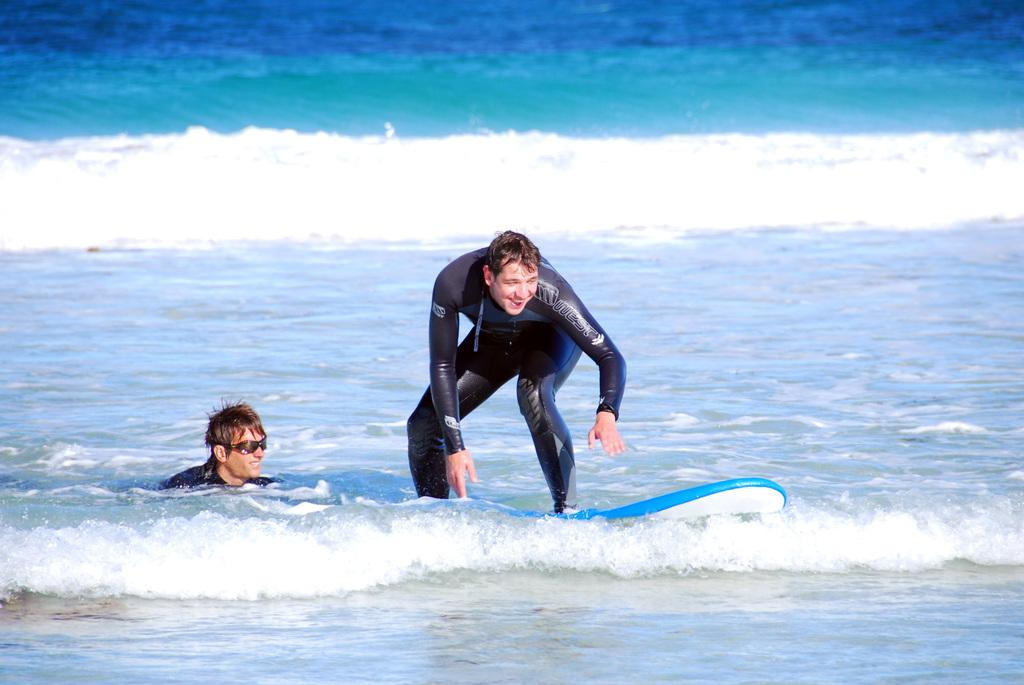How many people are in the image? There are two men in the image. What is one of the men doing in the image? One of the men is surfing on the water. What tool is the surfing man using? The man who is surfing is using a surfboard. What type of clam can be seen on the surfboard in the image? There is no clam present on the surfboard or in the image. What kind of beast is interacting with the surfing man in the image? There is no beast present in the image; it only features two men and a surfboard. 